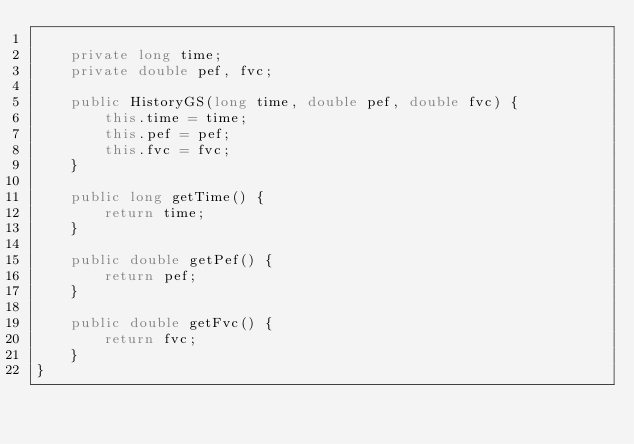Convert code to text. <code><loc_0><loc_0><loc_500><loc_500><_Java_>
    private long time;
    private double pef, fvc;

    public HistoryGS(long time, double pef, double fvc) {
        this.time = time;
        this.pef = pef;
        this.fvc = fvc;
    }

    public long getTime() {
        return time;
    }

    public double getPef() {
        return pef;
    }

    public double getFvc() {
        return fvc;
    }
}
</code> 